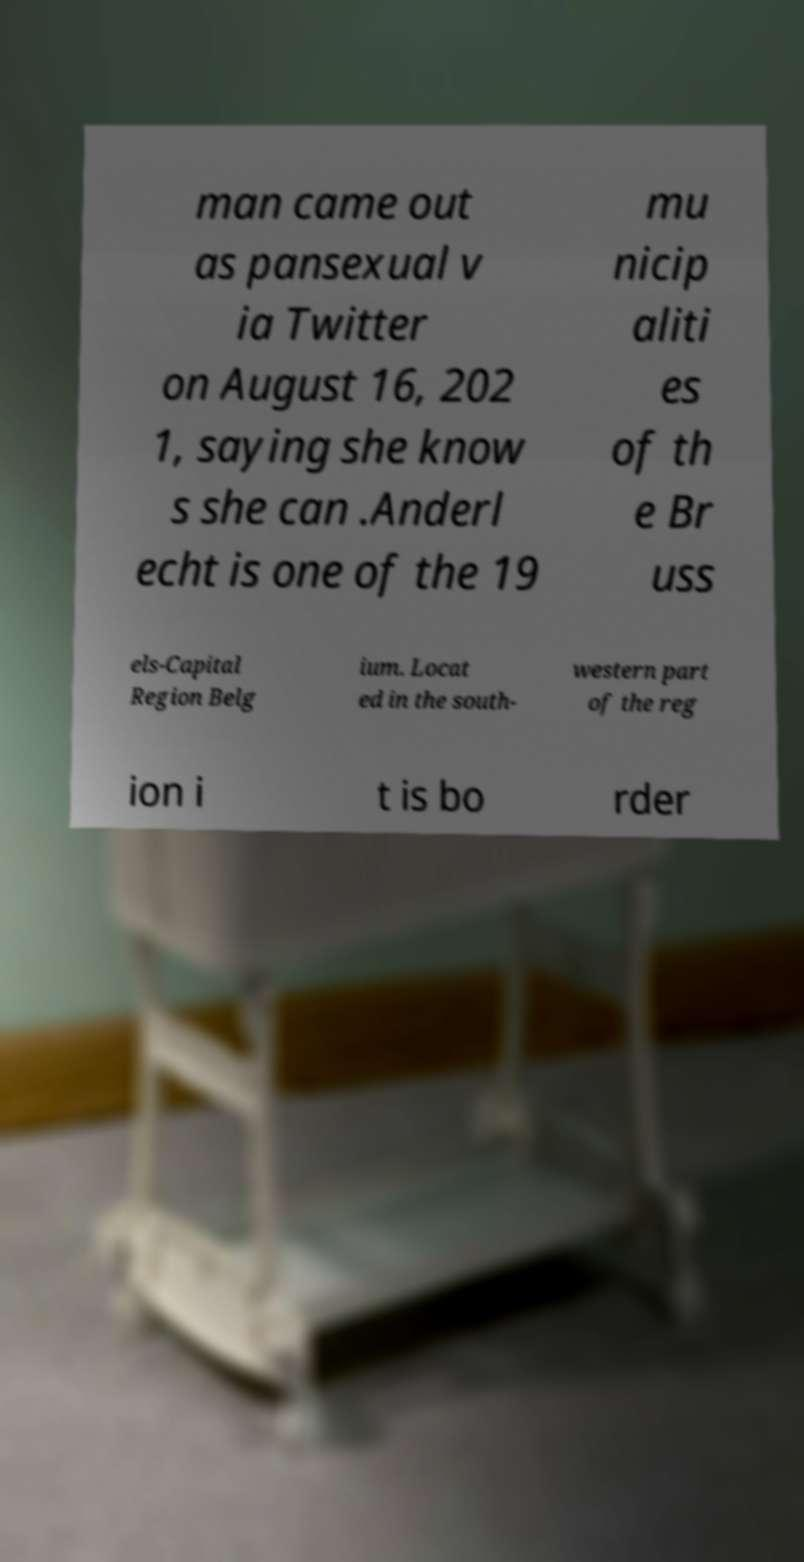Can you accurately transcribe the text from the provided image for me? man came out as pansexual v ia Twitter on August 16, 202 1, saying she know s she can .Anderl echt is one of the 19 mu nicip aliti es of th e Br uss els-Capital Region Belg ium. Locat ed in the south- western part of the reg ion i t is bo rder 